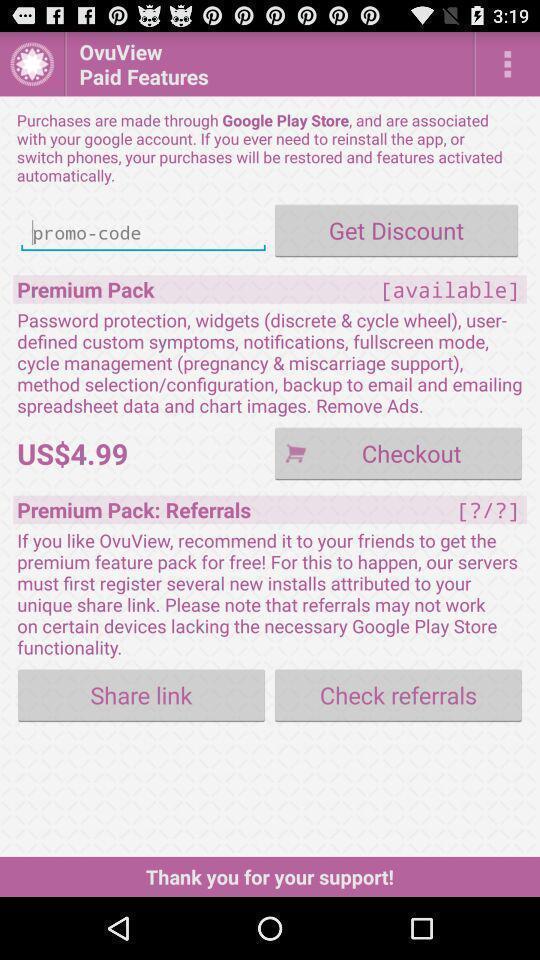Describe this image in words. Tracker application displaying code to get discount. 